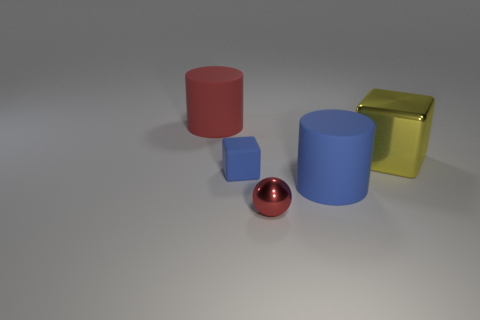Is the color of the large matte thing behind the large yellow metallic block the same as the sphere?
Ensure brevity in your answer.  Yes. There is a metal thing that is right of the shiny sphere; is its shape the same as the shiny thing that is in front of the metal block?
Offer a very short reply. No. How big is the matte object to the right of the red metal ball?
Provide a short and direct response. Large. There is a block that is in front of the block on the right side of the tiny shiny ball; how big is it?
Your response must be concise. Small. Is the number of large blue objects greater than the number of gray cylinders?
Provide a succinct answer. Yes. Is the number of red shiny objects that are on the right side of the large yellow thing greater than the number of big things that are behind the large blue rubber thing?
Your answer should be compact. No. What size is the matte object that is in front of the big shiny object and to the left of the large blue rubber cylinder?
Ensure brevity in your answer.  Small. How many matte things have the same size as the red sphere?
Provide a short and direct response. 1. There is a cylinder that is the same color as the small matte cube; what is it made of?
Your answer should be very brief. Rubber. There is a metal thing in front of the small blue matte cube; does it have the same shape as the small matte object?
Give a very brief answer. No. 